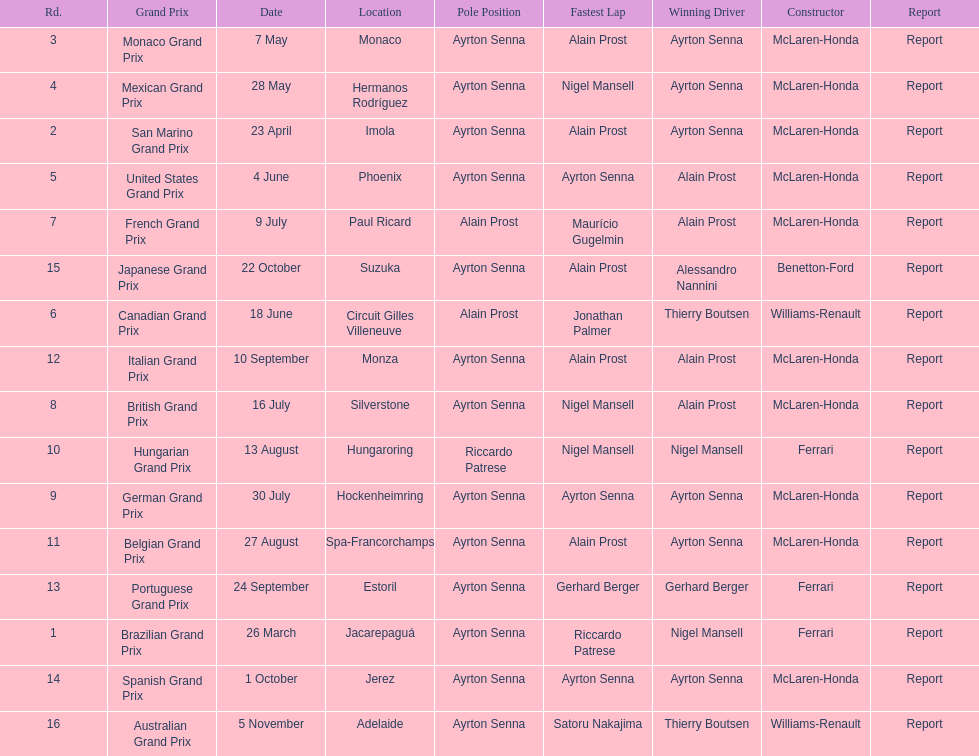Prost won the drivers title, who was his teammate? Ayrton Senna. 